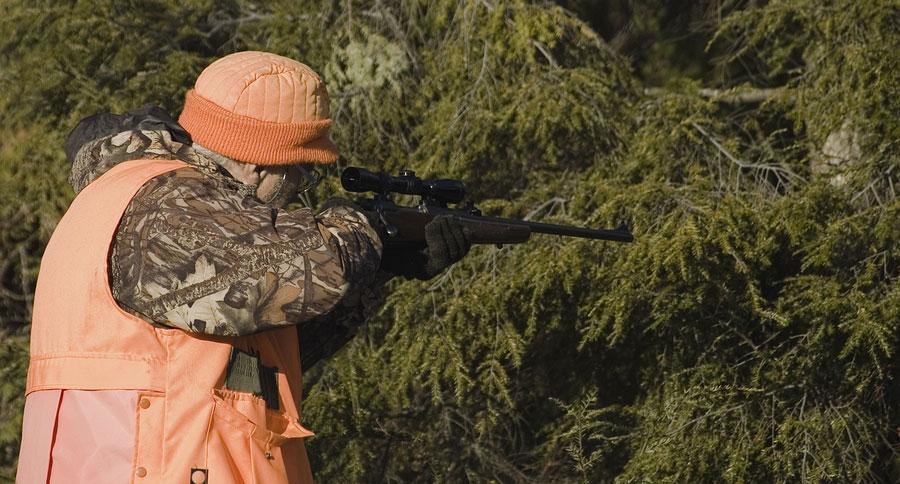Outline some significant characteristics in this image. There are 1-4 guns visible. The color of the gun is black, not white. 